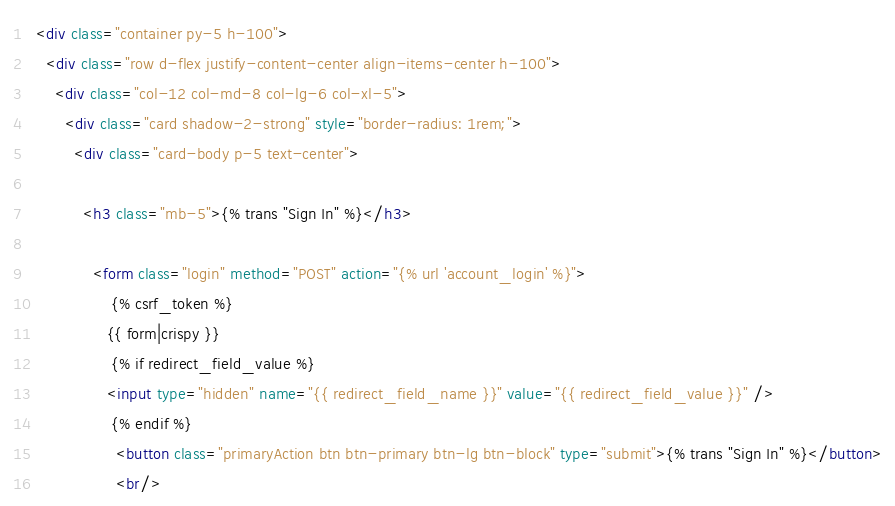Convert code to text. <code><loc_0><loc_0><loc_500><loc_500><_HTML_>  <div class="container py-5 h-100">
    <div class="row d-flex justify-content-center align-items-center h-100">
      <div class="col-12 col-md-8 col-lg-6 col-xl-5">
        <div class="card shadow-2-strong" style="border-radius: 1rem;">
          <div class="card-body p-5 text-center">

            <h3 class="mb-5">{% trans "Sign In" %}</h3>

              <form class="login" method="POST" action="{% url 'account_login' %}">
                  {% csrf_token %}
                 {{ form|crispy }}
                  {% if redirect_field_value %}
                 <input type="hidden" name="{{ redirect_field_name }}" value="{{ redirect_field_value }}" />
                  {% endif %}
                   <button class="primaryAction btn btn-primary btn-lg btn-block" type="submit">{% trans "Sign In" %}</button>
                   <br/></code> 